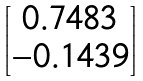Convert formula to latex. <formula><loc_0><loc_0><loc_500><loc_500>\begin{bmatrix} 0 . 7 4 8 3 \\ - 0 . 1 4 3 9 \end{bmatrix}</formula> 